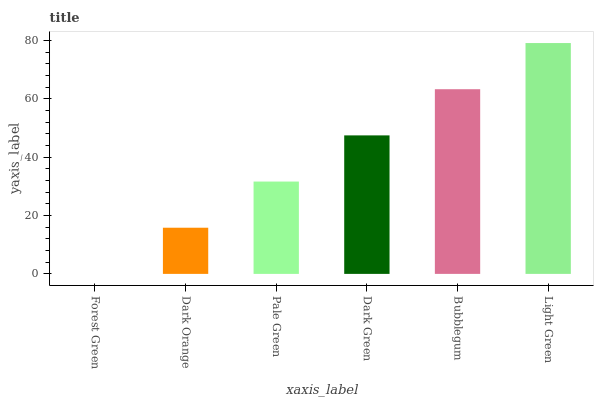Is Forest Green the minimum?
Answer yes or no. Yes. Is Light Green the maximum?
Answer yes or no. Yes. Is Dark Orange the minimum?
Answer yes or no. No. Is Dark Orange the maximum?
Answer yes or no. No. Is Dark Orange greater than Forest Green?
Answer yes or no. Yes. Is Forest Green less than Dark Orange?
Answer yes or no. Yes. Is Forest Green greater than Dark Orange?
Answer yes or no. No. Is Dark Orange less than Forest Green?
Answer yes or no. No. Is Dark Green the high median?
Answer yes or no. Yes. Is Pale Green the low median?
Answer yes or no. Yes. Is Dark Orange the high median?
Answer yes or no. No. Is Bubblegum the low median?
Answer yes or no. No. 